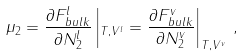<formula> <loc_0><loc_0><loc_500><loc_500>\mu _ { 2 } = \frac { \partial F _ { b u l k } ^ { l } } { \partial N _ { 2 } ^ { l } } \left | _ { T , V ^ { l } } = \frac { \partial F _ { b u l k } ^ { v } } { \partial N _ { 2 } ^ { v } } \right | _ { T , V ^ { v } } \, ,</formula> 